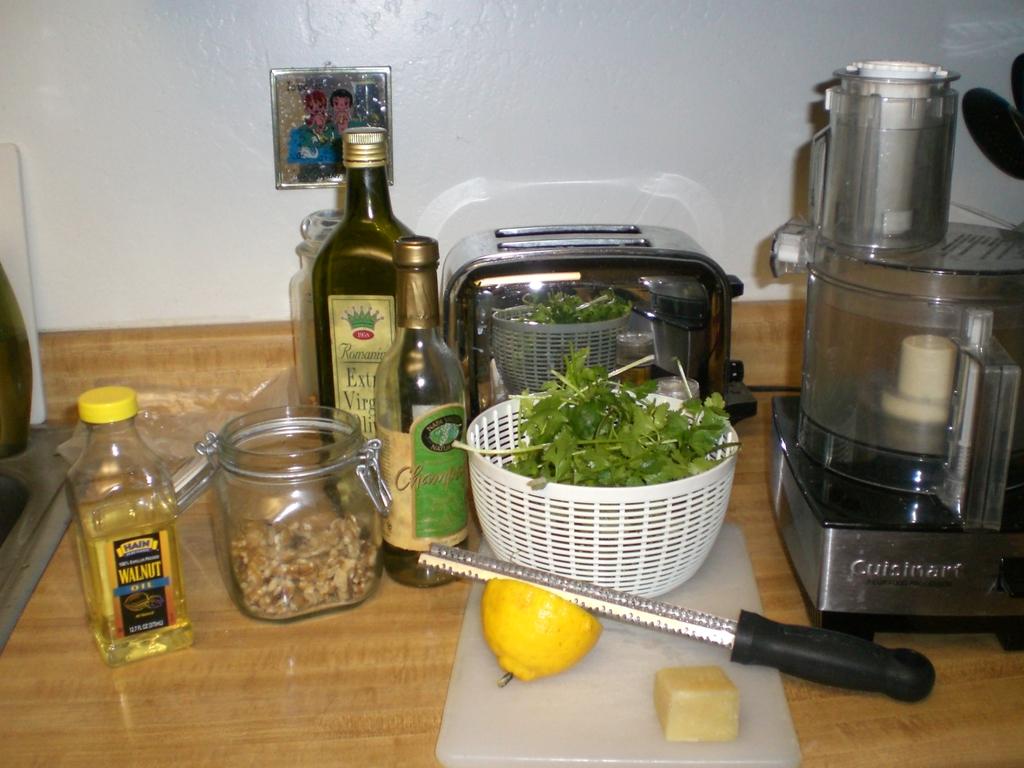Is this a kitchen?
Your answer should be very brief. Answering does not require reading text in the image. 